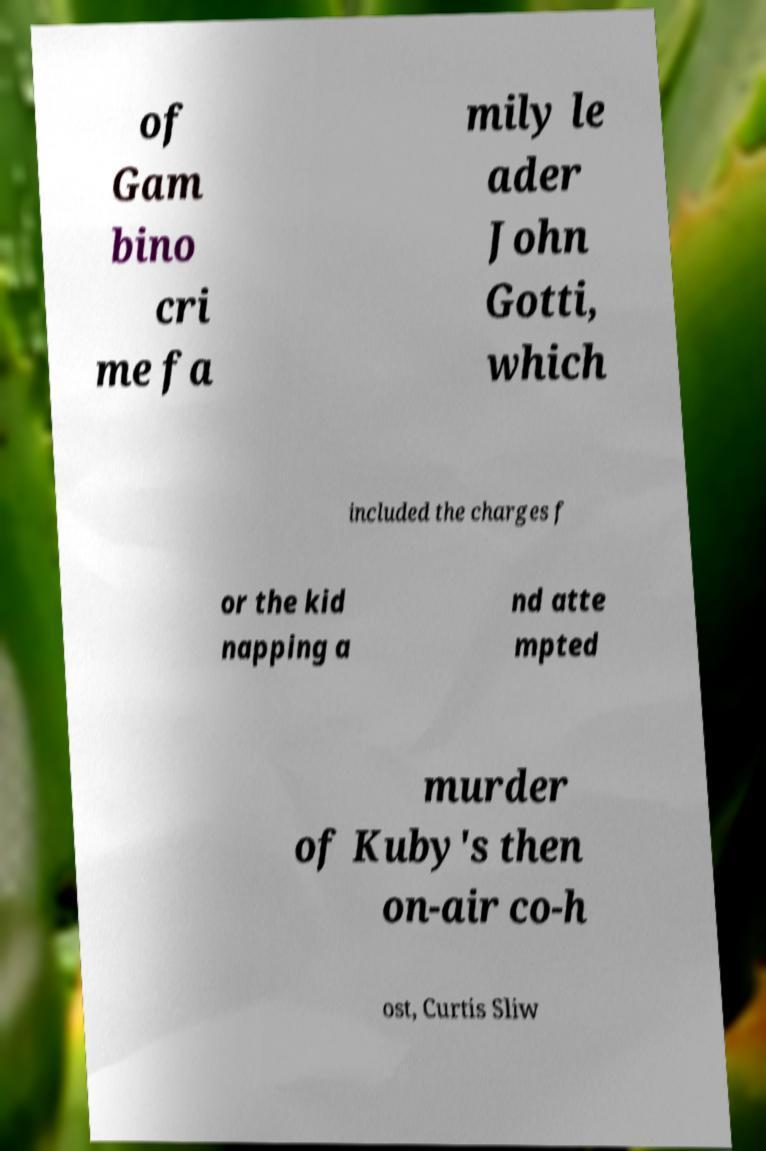Can you accurately transcribe the text from the provided image for me? of Gam bino cri me fa mily le ader John Gotti, which included the charges f or the kid napping a nd atte mpted murder of Kuby's then on-air co-h ost, Curtis Sliw 